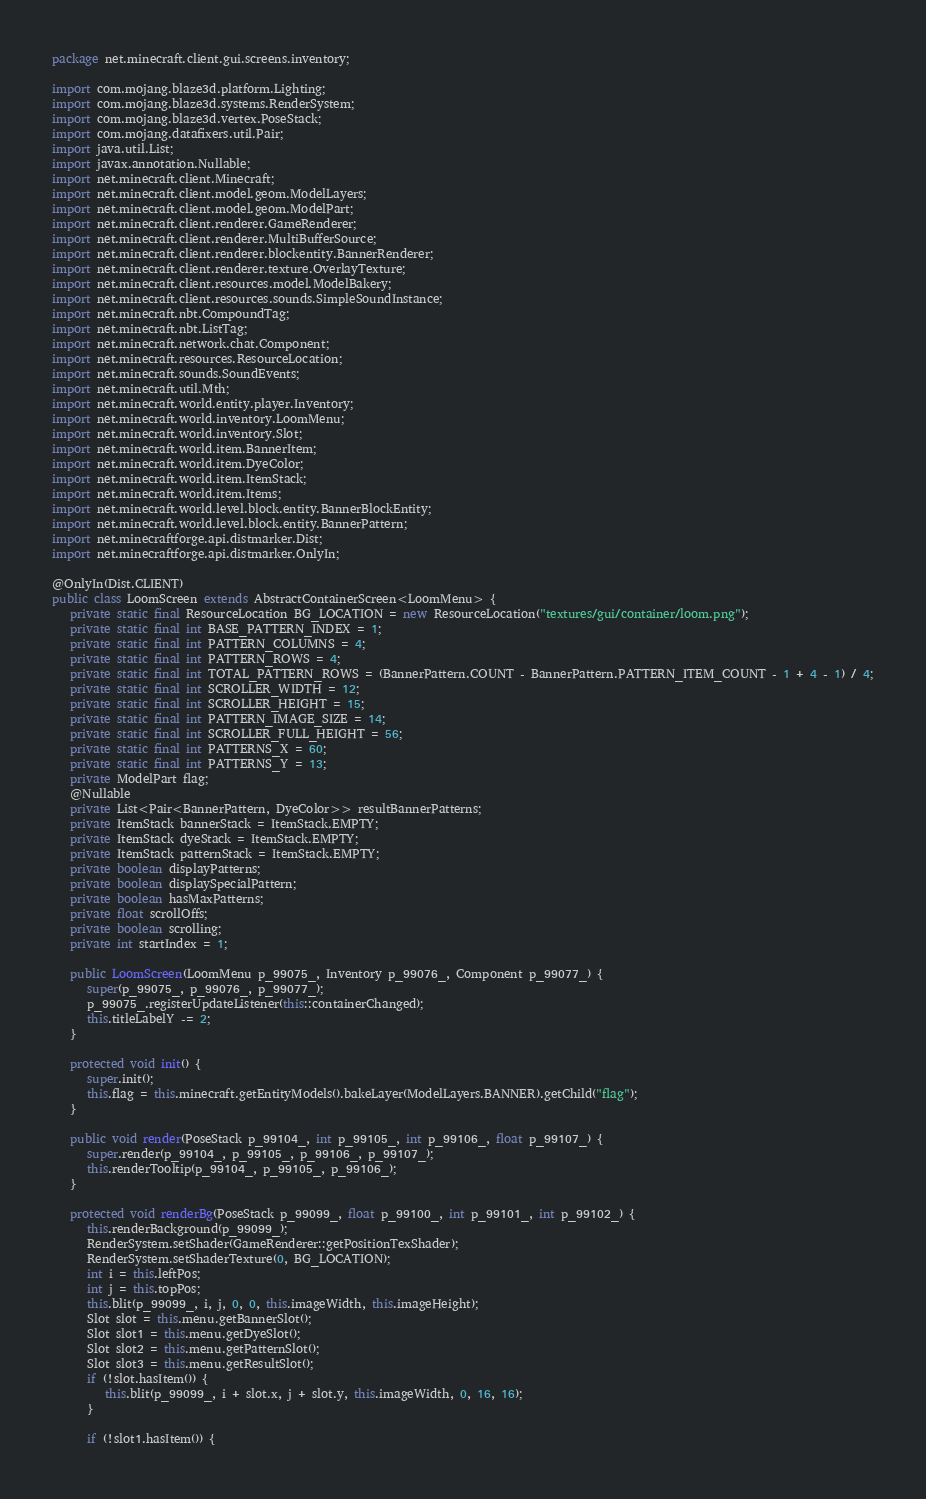Convert code to text. <code><loc_0><loc_0><loc_500><loc_500><_Java_>package net.minecraft.client.gui.screens.inventory;

import com.mojang.blaze3d.platform.Lighting;
import com.mojang.blaze3d.systems.RenderSystem;
import com.mojang.blaze3d.vertex.PoseStack;
import com.mojang.datafixers.util.Pair;
import java.util.List;
import javax.annotation.Nullable;
import net.minecraft.client.Minecraft;
import net.minecraft.client.model.geom.ModelLayers;
import net.minecraft.client.model.geom.ModelPart;
import net.minecraft.client.renderer.GameRenderer;
import net.minecraft.client.renderer.MultiBufferSource;
import net.minecraft.client.renderer.blockentity.BannerRenderer;
import net.minecraft.client.renderer.texture.OverlayTexture;
import net.minecraft.client.resources.model.ModelBakery;
import net.minecraft.client.resources.sounds.SimpleSoundInstance;
import net.minecraft.nbt.CompoundTag;
import net.minecraft.nbt.ListTag;
import net.minecraft.network.chat.Component;
import net.minecraft.resources.ResourceLocation;
import net.minecraft.sounds.SoundEvents;
import net.minecraft.util.Mth;
import net.minecraft.world.entity.player.Inventory;
import net.minecraft.world.inventory.LoomMenu;
import net.minecraft.world.inventory.Slot;
import net.minecraft.world.item.BannerItem;
import net.minecraft.world.item.DyeColor;
import net.minecraft.world.item.ItemStack;
import net.minecraft.world.item.Items;
import net.minecraft.world.level.block.entity.BannerBlockEntity;
import net.minecraft.world.level.block.entity.BannerPattern;
import net.minecraftforge.api.distmarker.Dist;
import net.minecraftforge.api.distmarker.OnlyIn;

@OnlyIn(Dist.CLIENT)
public class LoomScreen extends AbstractContainerScreen<LoomMenu> {
   private static final ResourceLocation BG_LOCATION = new ResourceLocation("textures/gui/container/loom.png");
   private static final int BASE_PATTERN_INDEX = 1;
   private static final int PATTERN_COLUMNS = 4;
   private static final int PATTERN_ROWS = 4;
   private static final int TOTAL_PATTERN_ROWS = (BannerPattern.COUNT - BannerPattern.PATTERN_ITEM_COUNT - 1 + 4 - 1) / 4;
   private static final int SCROLLER_WIDTH = 12;
   private static final int SCROLLER_HEIGHT = 15;
   private static final int PATTERN_IMAGE_SIZE = 14;
   private static final int SCROLLER_FULL_HEIGHT = 56;
   private static final int PATTERNS_X = 60;
   private static final int PATTERNS_Y = 13;
   private ModelPart flag;
   @Nullable
   private List<Pair<BannerPattern, DyeColor>> resultBannerPatterns;
   private ItemStack bannerStack = ItemStack.EMPTY;
   private ItemStack dyeStack = ItemStack.EMPTY;
   private ItemStack patternStack = ItemStack.EMPTY;
   private boolean displayPatterns;
   private boolean displaySpecialPattern;
   private boolean hasMaxPatterns;
   private float scrollOffs;
   private boolean scrolling;
   private int startIndex = 1;

   public LoomScreen(LoomMenu p_99075_, Inventory p_99076_, Component p_99077_) {
      super(p_99075_, p_99076_, p_99077_);
      p_99075_.registerUpdateListener(this::containerChanged);
      this.titleLabelY -= 2;
   }

   protected void init() {
      super.init();
      this.flag = this.minecraft.getEntityModels().bakeLayer(ModelLayers.BANNER).getChild("flag");
   }

   public void render(PoseStack p_99104_, int p_99105_, int p_99106_, float p_99107_) {
      super.render(p_99104_, p_99105_, p_99106_, p_99107_);
      this.renderTooltip(p_99104_, p_99105_, p_99106_);
   }

   protected void renderBg(PoseStack p_99099_, float p_99100_, int p_99101_, int p_99102_) {
      this.renderBackground(p_99099_);
      RenderSystem.setShader(GameRenderer::getPositionTexShader);
      RenderSystem.setShaderTexture(0, BG_LOCATION);
      int i = this.leftPos;
      int j = this.topPos;
      this.blit(p_99099_, i, j, 0, 0, this.imageWidth, this.imageHeight);
      Slot slot = this.menu.getBannerSlot();
      Slot slot1 = this.menu.getDyeSlot();
      Slot slot2 = this.menu.getPatternSlot();
      Slot slot3 = this.menu.getResultSlot();
      if (!slot.hasItem()) {
         this.blit(p_99099_, i + slot.x, j + slot.y, this.imageWidth, 0, 16, 16);
      }

      if (!slot1.hasItem()) {</code> 